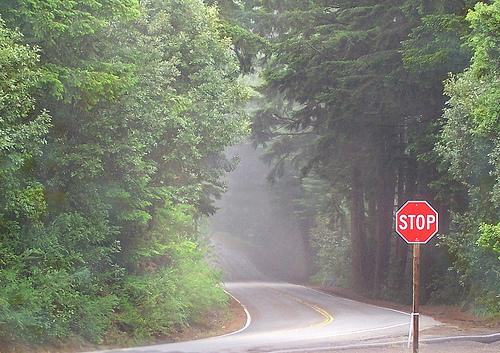Identify the significant features of the image and describe their appearance. The standout features of this image include a bright red stop sign with white text, a brown pole, a paved road with yellow lines, and lush greenery along the roadside. Provide a brief overview of the primary elements in the image. The main focus of the image is a red and white stop sign on a wooden pole, situated along a gray paved road with yellow markings, surrounded by trees and greenery. Tell a story about the image focusing on the main subject and its environment. Once upon a foggy morning, a red stop sign with bold white letters stood steadfast on a wooden pole, guiding travelers through a winding, gray road lined with vibrant trees and bushes. Provide a poetic description of the scene and its surroundings captured in the image.  In this dreamy landscape, a bold red sentinel with white commandments graces a wooden pole, guiding our journey through the sun-dappled road, embraced by the forest's leafy serenade. Examine the picture and provide a straightforward description of its primary contents. There is a red and white stop sign on a wooden pole, yellow lines on a gray road, and green trees and dirt on the side of the road in the image. Mention the significant elements in the image and their visual characteristics. The image features a red stop sign with white letters, a wooden pole, a gray paved road with yellow lines, green trees, dirt and bushes on the roadside, and sunlight shining through the fog. Narrate the picture by mentioning the most notable objects and their attributes. A red octagonal stop sign with white lettering stands on a wooden pole near a winding gray road with yellow lines, while tall green trees and bushes line the roadside. Give an artistic description of the image highlighting the primary elements and their ambiance. A vivid tableau unfolds, with a bold red stop sign on aged wooden pole as the centerpiece, set against the gray roadway adorned with yellow lines and framed by a lush, green woodland. Describe the central part of the image, mentioning its features and surroundings. A red stop sign with contrasting white letters on a wooden pole is located near a gray paved road with yellow lines, amidst a verdant forest with tall trees and bushes. Analyze the image and provide a description that emphasizes the central object and its surroundings. Dominating the scene is a vibrant red stop sign, emblazoned with white letters, mounted on a sturdy wooden pole. It stands proudly near a curving gray road with yellow lines and enveloped by verdant foliage. 